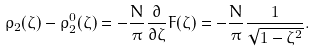Convert formula to latex. <formula><loc_0><loc_0><loc_500><loc_500>\rho _ { 2 } ( \zeta ) - \rho _ { 2 } ^ { 0 } ( \zeta ) = - \frac { N } { \pi } \frac { \partial } { \partial \zeta } F ( \zeta ) = - \frac { N } { \pi } \frac { 1 } { \sqrt { 1 - \zeta ^ { 2 } } } .</formula> 